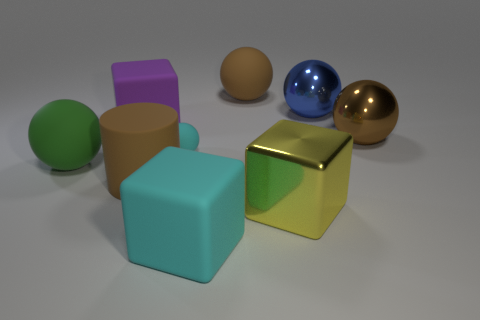There is a big cyan object that is the same shape as the large yellow metallic object; what material is it?
Your answer should be very brief. Rubber. How many objects are yellow metallic cubes that are on the right side of the big purple thing or rubber blocks that are left of the cyan block?
Offer a terse response. 2. There is a big metallic thing that is both left of the big brown metallic thing and to the right of the large yellow metallic object; what shape is it?
Give a very brief answer. Sphere. There is a rubber sphere that is behind the blue thing; how many tiny spheres are to the right of it?
Offer a terse response. 0. Is there anything else that has the same material as the large purple thing?
Provide a short and direct response. Yes. How many objects are either tiny cyan matte objects to the left of the blue thing or big yellow metal things?
Offer a very short reply. 2. What is the size of the rubber cube left of the big matte cylinder?
Make the answer very short. Large. What material is the cylinder?
Keep it short and to the point. Rubber. What is the shape of the brown thing on the left side of the large brown rubber thing that is behind the green sphere?
Provide a short and direct response. Cylinder. How many other objects are there of the same shape as the tiny cyan thing?
Offer a very short reply. 4. 